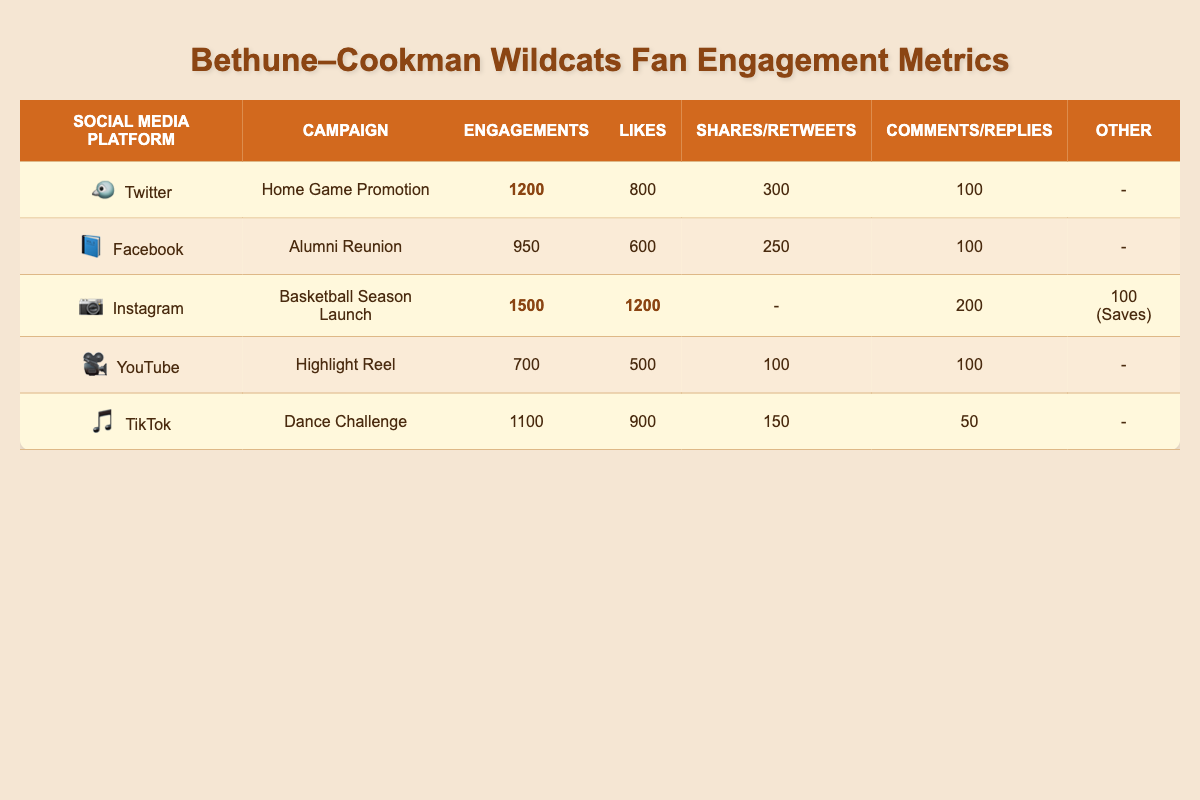What is the total number of engagements across all campaigns? To find the total number of engagements, add the engagements from each campaign: 1200 (Twitter) + 950 (Facebook) + 1500 (Instagram) + 700 (YouTube) + 1100 (TikTok) = 4450
Answer: 4450 Which social media platform had the highest number of likes? Referring to the Likes column, Instagram has the highest with 1200 likes compared to Twitter's 800, Facebook's 600, YouTube's 500, and TikTok's 900
Answer: Instagram Did the TikTok campaign receive more comments than the YouTube campaign? TikTok received 50 comments, while YouTube received 100 comments. Since 50 is less than 100, the answer is no
Answer: No What is the difference in engagements between the Instagram campaign and the Facebook campaign? Instagram had 1500 engagements and Facebook had 950 engagements. The difference is 1500 - 950 = 550
Answer: 550 How many total shares and retweets were recorded for the Twitter and TikTok campaigns combined? Twitter had 300 retweets and TikTok had 150 shares. Adding these gives a total of 300 + 150 = 450
Answer: 450 What percentage of the total engagements came from the Instagram campaign? First, find the total engagements, which is 4450. The Instagram engagements are 1500. To find the percentage, divide 1500 by 4450 and multiply by 100. It equals (1500 / 4450) * 100 ≈ 33.7%
Answer: Approximately 33.7% Is it true that the Facebook campaign had more total engagements than the YouTube campaign? Facebook had 950 engagements, while YouTube had 700 engagements. Since 950 is greater than 700, the answer is yes
Answer: Yes What is the average number of likes per campaign? Sum the likes: 800 (Twitter) + 600 (Facebook) + 1200 (Instagram) + 500 (YouTube) + 900 (TikTok) = 4000. Divide by the number of campaigns (5): 4000 / 5 = 800
Answer: 800 Which campaign had the least number of total engagements? Looking at the Engagements column, YouTube with 700 engagements is the lowest compared to others (Twitter 1200, Facebook 950, Instagram 1500, TikTok 1100)
Answer: YouTube 